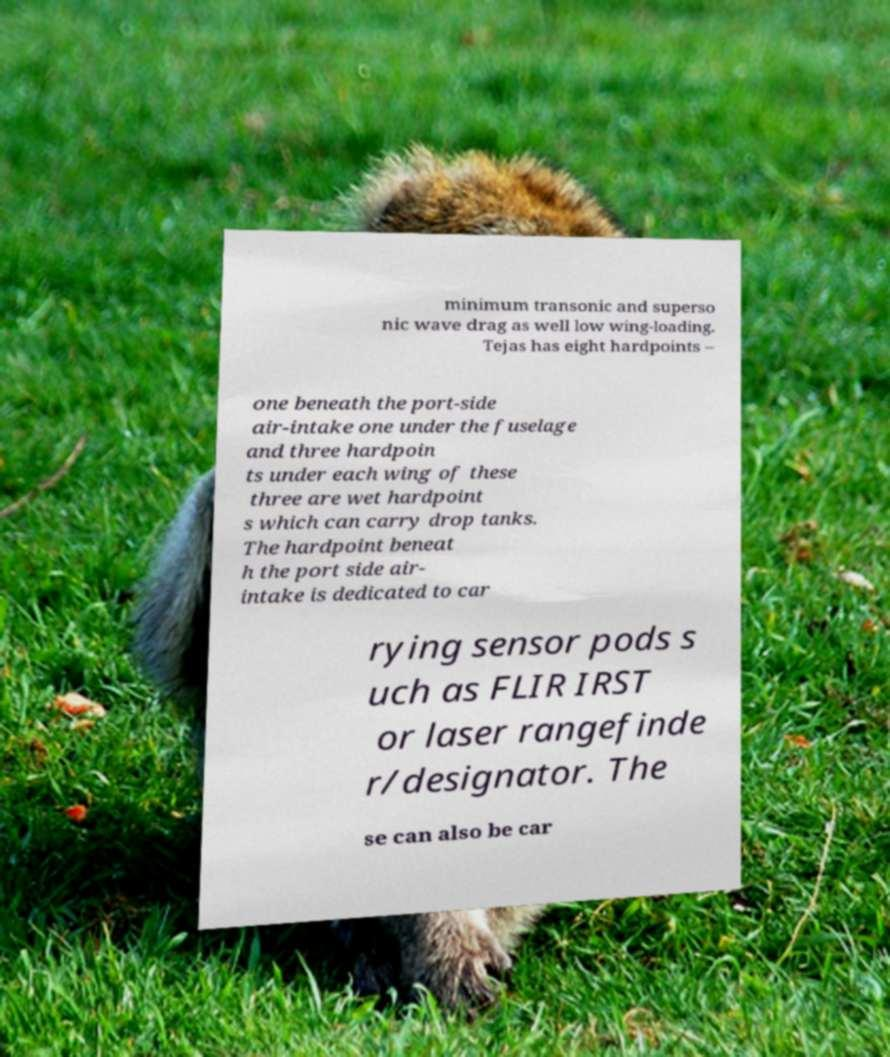There's text embedded in this image that I need extracted. Can you transcribe it verbatim? minimum transonic and superso nic wave drag as well low wing-loading. Tejas has eight hardpoints – one beneath the port-side air-intake one under the fuselage and three hardpoin ts under each wing of these three are wet hardpoint s which can carry drop tanks. The hardpoint beneat h the port side air- intake is dedicated to car rying sensor pods s uch as FLIR IRST or laser rangefinde r/designator. The se can also be car 